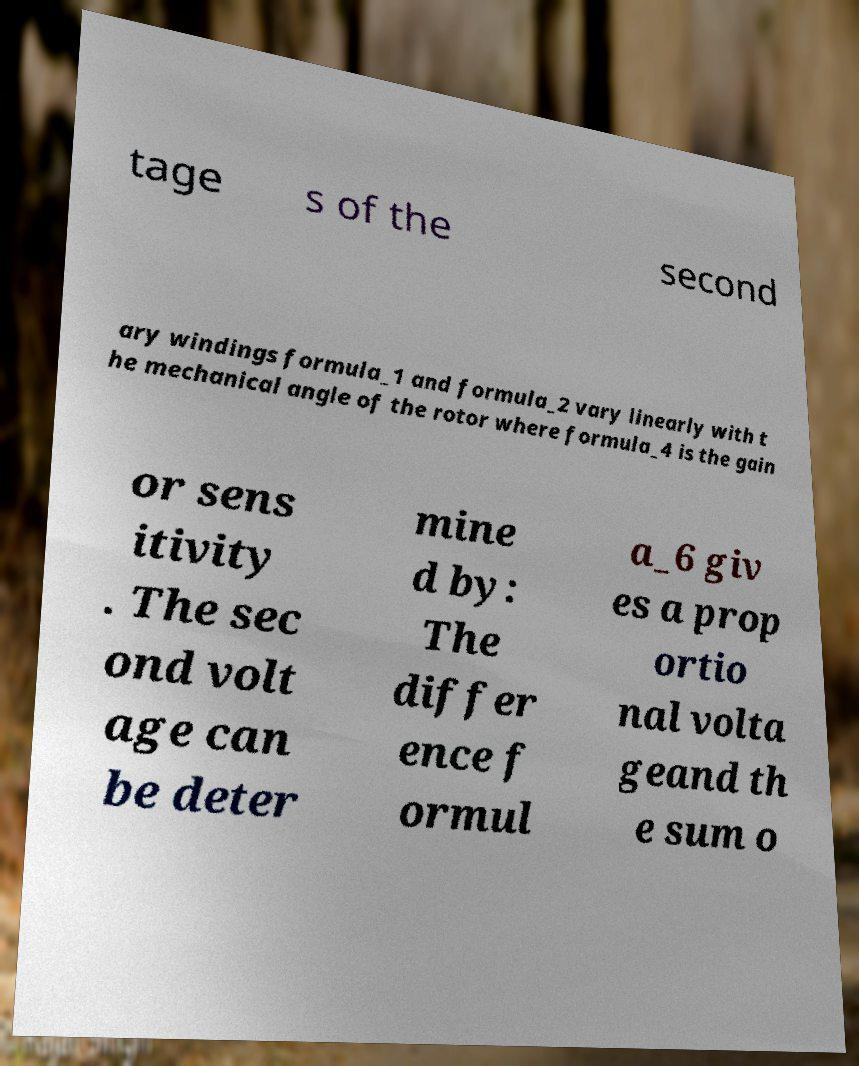Please read and relay the text visible in this image. What does it say? tage s of the second ary windings formula_1 and formula_2 vary linearly with t he mechanical angle of the rotor where formula_4 is the gain or sens itivity . The sec ond volt age can be deter mine d by: The differ ence f ormul a_6 giv es a prop ortio nal volta geand th e sum o 